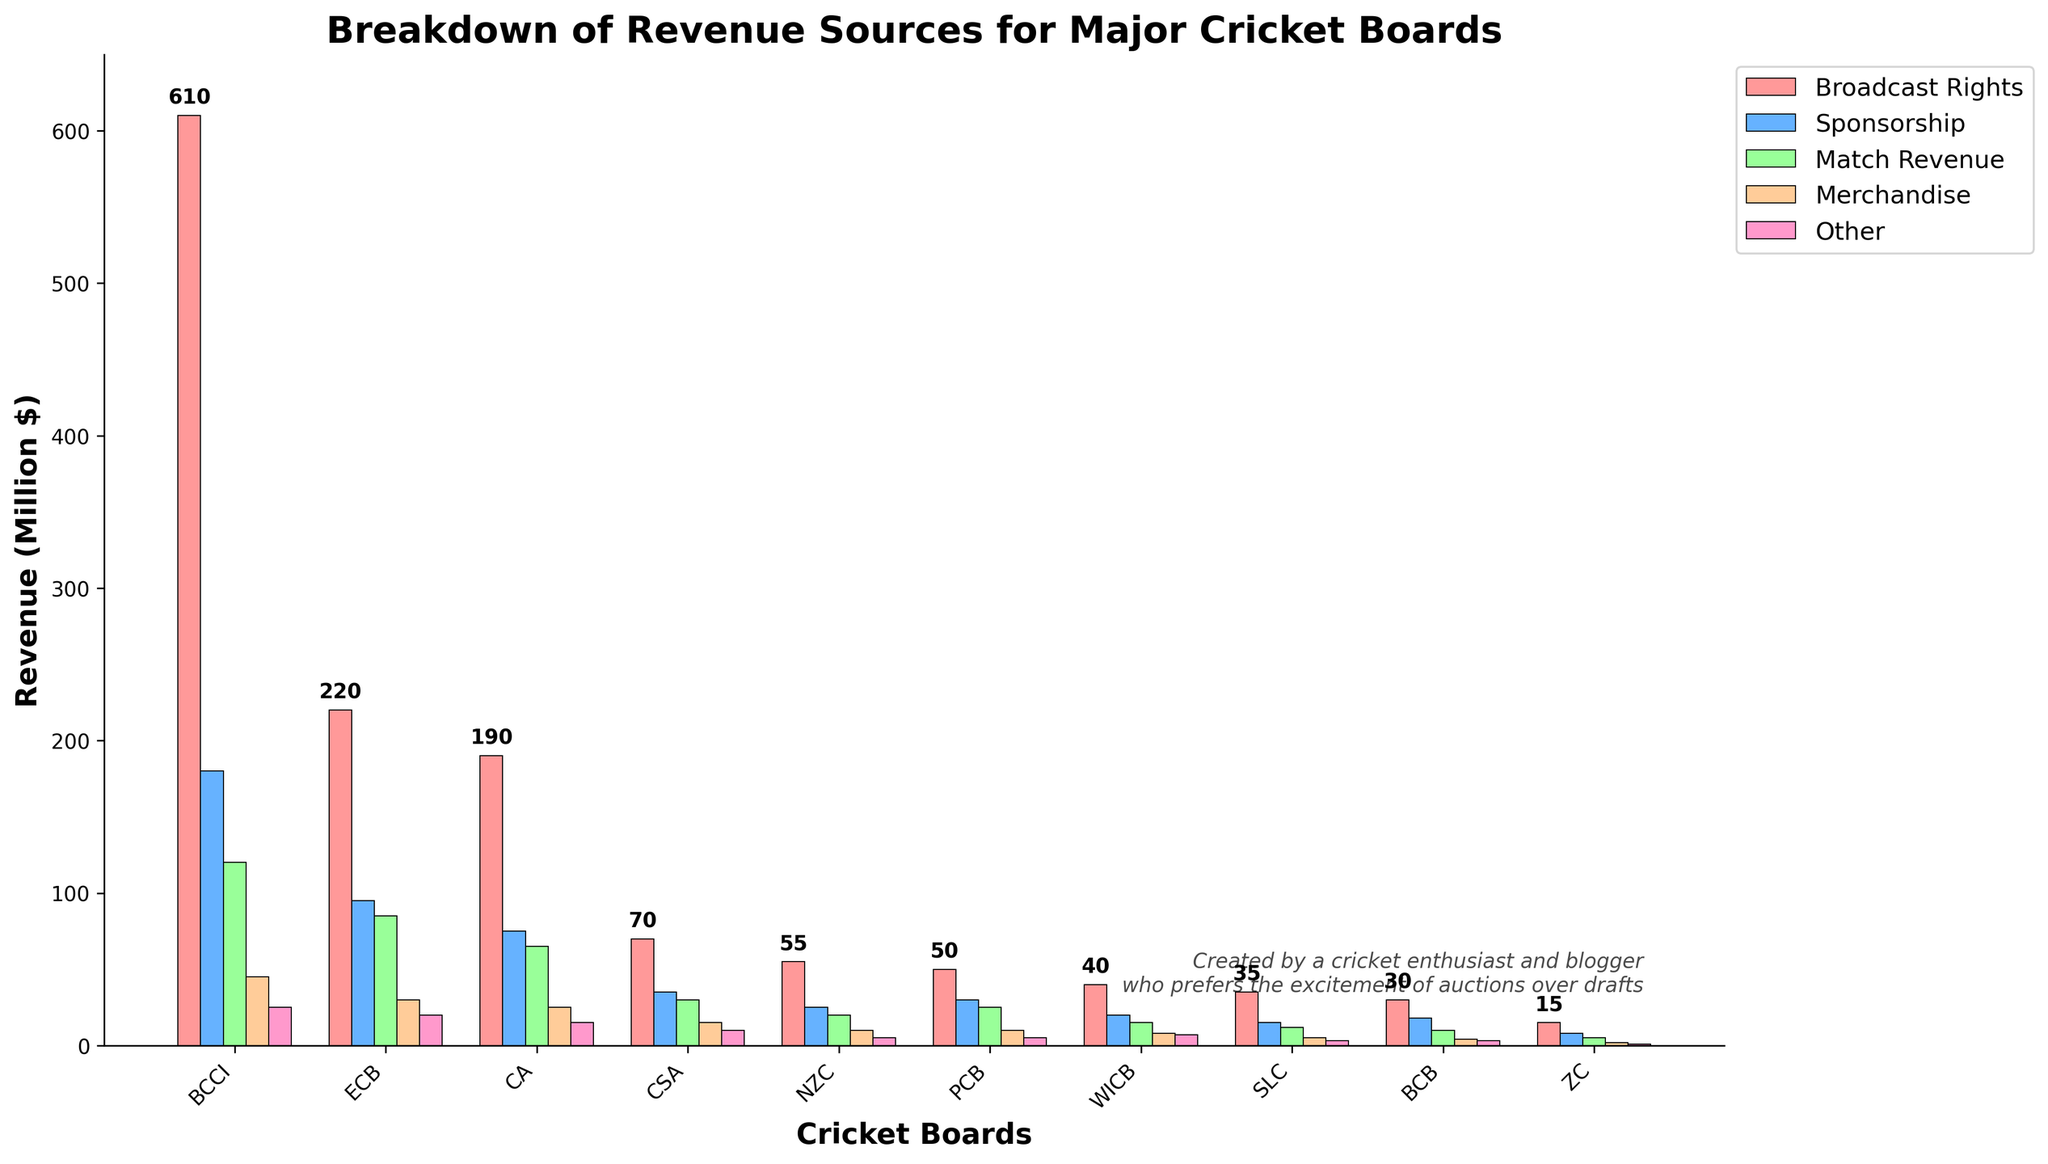Which cricket board has the highest revenue from broadcast rights? The BCCI has the highest bar in the "Broadcast Rights" category.
Answer: BCCI Which cricket board earns more from merchandise, ECB or CA? ECB earns 30 million dollars from merchandise, while CA earns 25 million dollars, making ECB the higher earner in this category.
Answer: ECB What is the total revenue of ECB from all sources combined? Sum the ECB revenues from all categories: 220 (Broadcast Rights) + 95 (Sponsorship) + 85 (Match Revenue) + 30 (Merchandise) + 20 (Other) = 450 million dollars.
Answer: 450 million dollars How does CA's revenue from sponsorship compare to CSA's total revenue? CA earns 75 million dollars from sponsorship, while CSA's total revenue is 70 + 35 + 30 + 15 + 10 = 160 million dollars. CA's sponsorship revenue is less than CSA's total revenue.
Answer: Less Which cricket board has the lowest revenue from match revenue? ZC has the lowest bar in the "Match Revenue" category with 5 million dollars.
Answer: ZC What is the difference between BCCI's and WICB's total revenue? BCCI's total revenue is 610 + 180 + 120 + 45 + 25 = 980 million dollars. WICB's total revenue is 40 + 20 + 15 + 8 + 7 = 90 million dollars. The difference is 980 - 90 = 890 million dollars.
Answer: 890 million dollars Which cricket board has the biggest proportion of its revenue coming from broadcast rights? Calculate the proportion of broadcast rights revenue for each board and compare. BCCI: 610/980, ECB: 220/450, CA: 190/370, CSA: 70/160, NZC: 55/115, PCB: 50/120, WICB: 40/90, SLC: 35/70, BCB: 30/65, ZC: 15/31. BCCI has the highest proportion.
Answer: BCCI What is the combined revenue from sponsorships of ECB and SLC? ECB: 95 million dollars, SLC: 15 million dollars. Combined revenue is 95 + 15 = 110 million dollars.
Answer: 110 million dollars If you combine the revenues of ZC and BCB, which cricket board would they be most similar to in terms of total revenue? ZC's total revenue is 31 million dollars, BCB's total revenue is 65 million dollars, so combined they make 31 + 65 = 96 million dollars. This is most similar to WICB, which has 90 million dollars total revenue.
Answer: WICB 